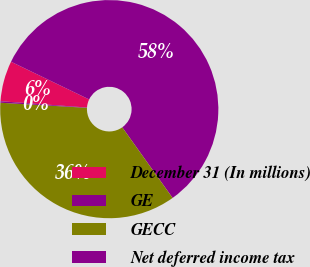<chart> <loc_0><loc_0><loc_500><loc_500><pie_chart><fcel>December 31 (In millions)<fcel>GE<fcel>GECC<fcel>Net deferred income tax<nl><fcel>6.0%<fcel>57.99%<fcel>35.79%<fcel>0.22%<nl></chart> 